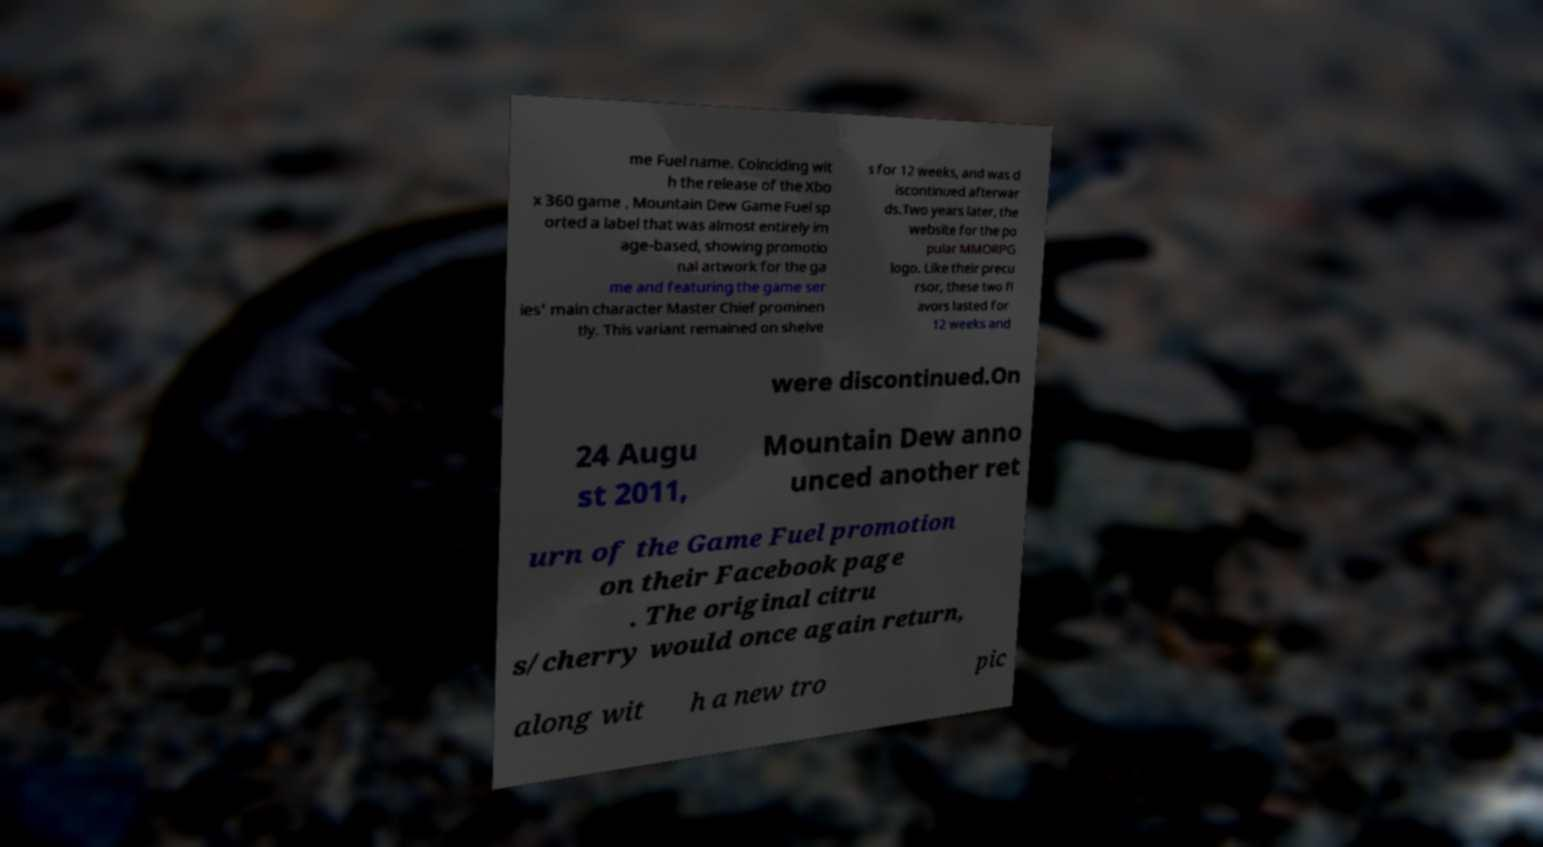There's text embedded in this image that I need extracted. Can you transcribe it verbatim? me Fuel name. Coinciding wit h the release of the Xbo x 360 game , Mountain Dew Game Fuel sp orted a label that was almost entirely im age-based, showing promotio nal artwork for the ga me and featuring the game ser ies' main character Master Chief prominen tly. This variant remained on shelve s for 12 weeks, and was d iscontinued afterwar ds.Two years later, the website for the po pular MMORPG logo. Like their precu rsor, these two fl avors lasted for 12 weeks and were discontinued.On 24 Augu st 2011, Mountain Dew anno unced another ret urn of the Game Fuel promotion on their Facebook page . The original citru s/cherry would once again return, along wit h a new tro pic 